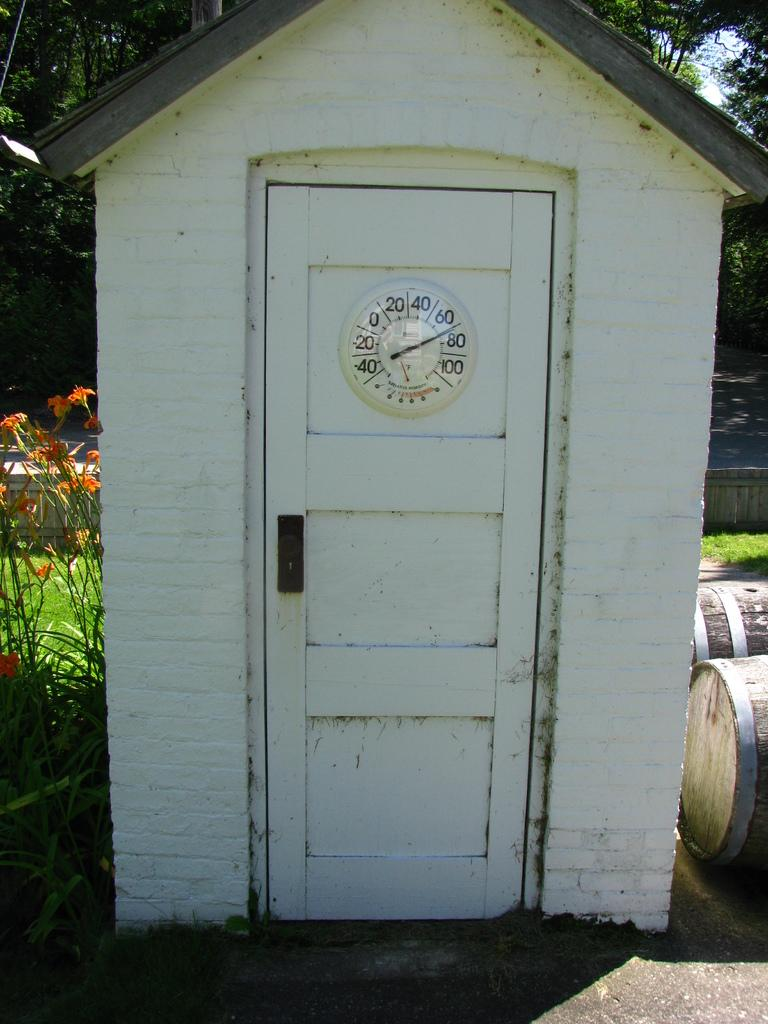<image>
Relay a brief, clear account of the picture shown. A thermometer has the numbers to, 40, 60, and others around the outer edge. 